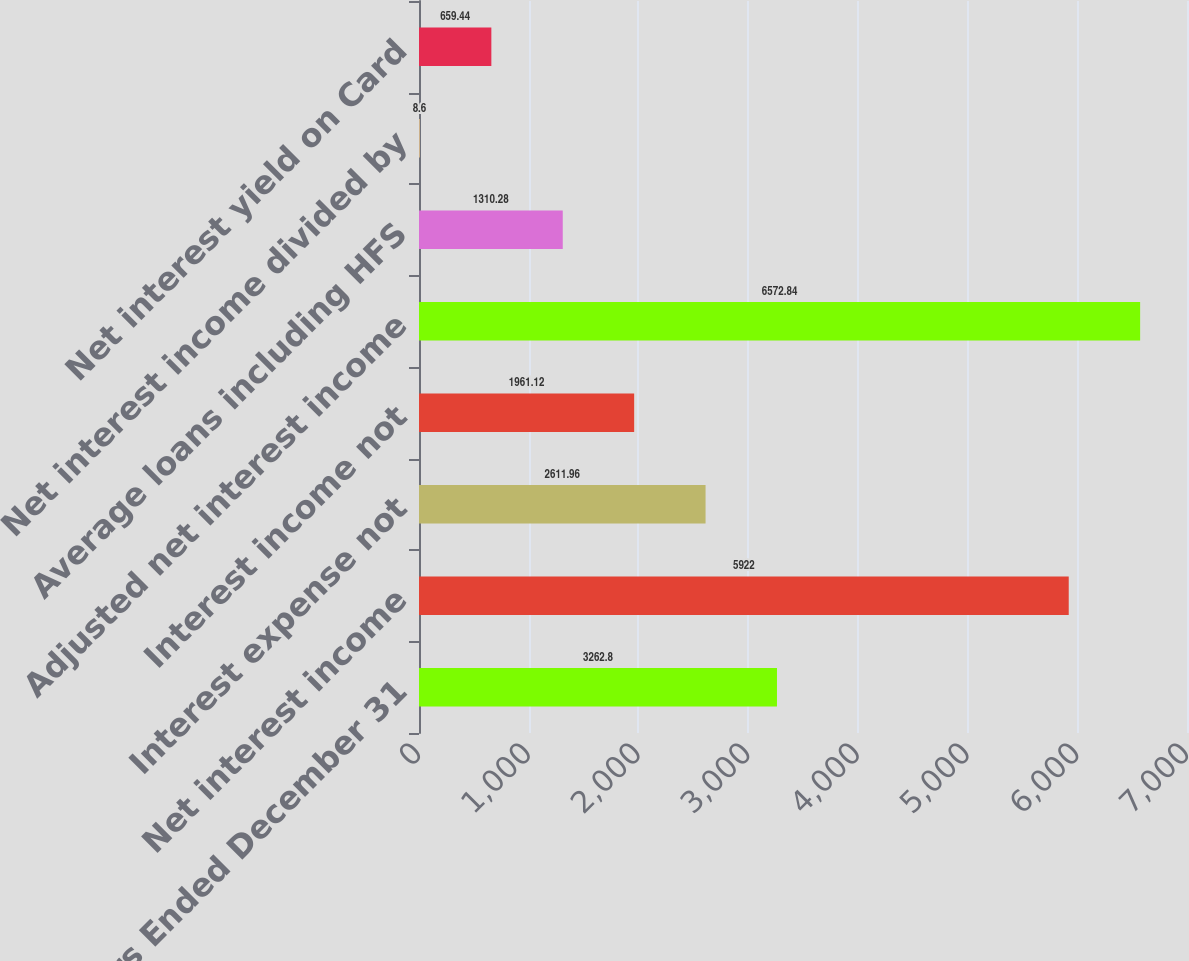Convert chart. <chart><loc_0><loc_0><loc_500><loc_500><bar_chart><fcel>Years Ended December 31<fcel>Net interest income<fcel>Interest expense not<fcel>Interest income not<fcel>Adjusted net interest income<fcel>Average loans including HFS<fcel>Net interest income divided by<fcel>Net interest yield on Card<nl><fcel>3262.8<fcel>5922<fcel>2611.96<fcel>1961.12<fcel>6572.84<fcel>1310.28<fcel>8.6<fcel>659.44<nl></chart> 